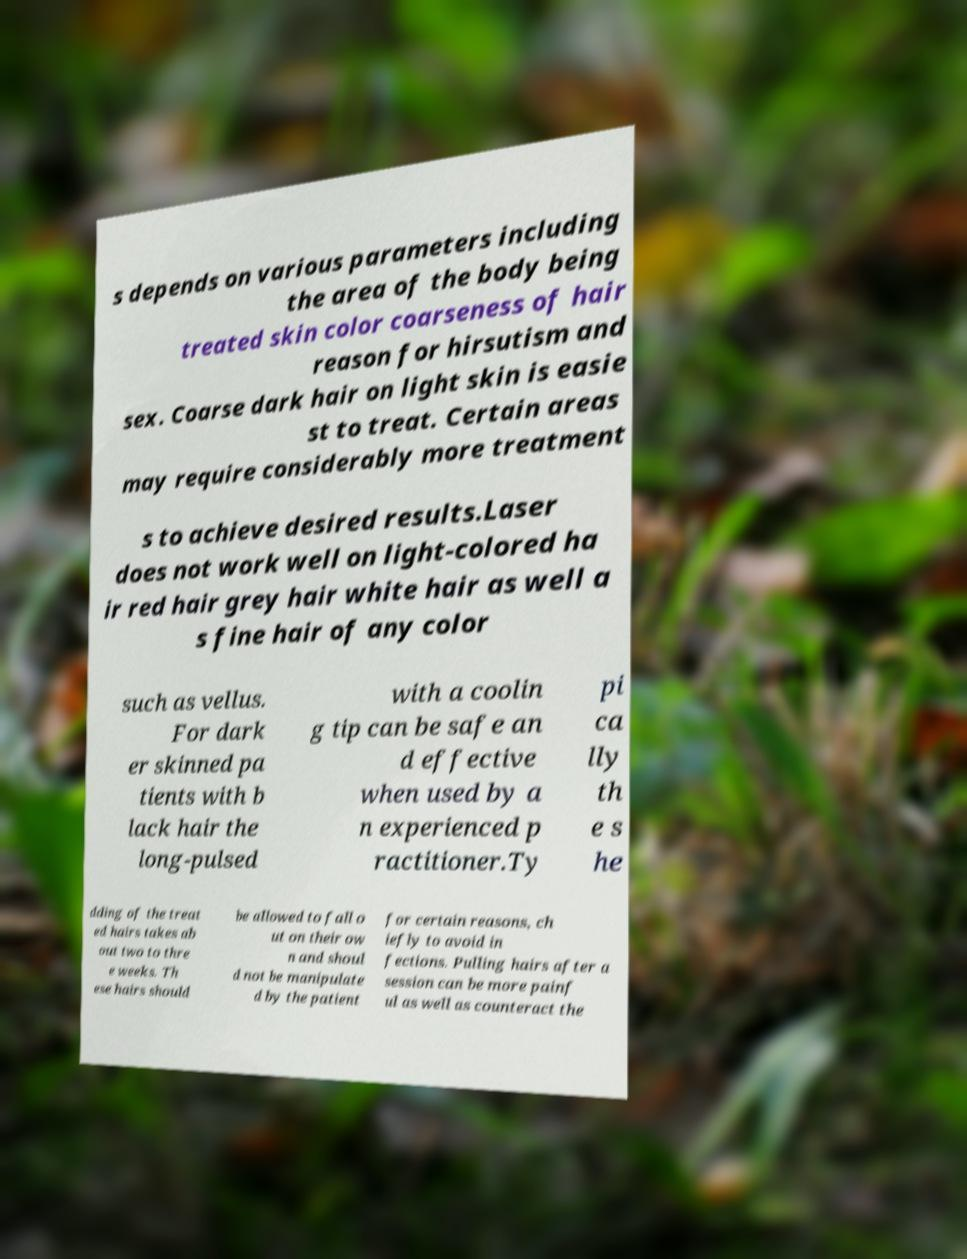What messages or text are displayed in this image? I need them in a readable, typed format. s depends on various parameters including the area of the body being treated skin color coarseness of hair reason for hirsutism and sex. Coarse dark hair on light skin is easie st to treat. Certain areas may require considerably more treatment s to achieve desired results.Laser does not work well on light-colored ha ir red hair grey hair white hair as well a s fine hair of any color such as vellus. For dark er skinned pa tients with b lack hair the long-pulsed with a coolin g tip can be safe an d effective when used by a n experienced p ractitioner.Ty pi ca lly th e s he dding of the treat ed hairs takes ab out two to thre e weeks. Th ese hairs should be allowed to fall o ut on their ow n and shoul d not be manipulate d by the patient for certain reasons, ch iefly to avoid in fections. Pulling hairs after a session can be more painf ul as well as counteract the 